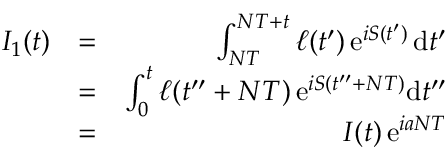<formula> <loc_0><loc_0><loc_500><loc_500>\begin{array} { r l r } { I _ { 1 } ( t ) } & { = } & { \int _ { N T } ^ { N T + t } \ell ( t ^ { \prime } ) \, e ^ { i S ( t ^ { \prime } ) } \, d t ^ { \prime } } \\ & { = } & { \int _ { 0 } ^ { t } \ell ( t ^ { \prime \prime } + N T ) \, e ^ { i S ( t ^ { \prime \prime } + N T ) } d t ^ { \prime \prime } } \\ & { = } & { I ( t ) \, e ^ { i a N T } } \end{array}</formula> 